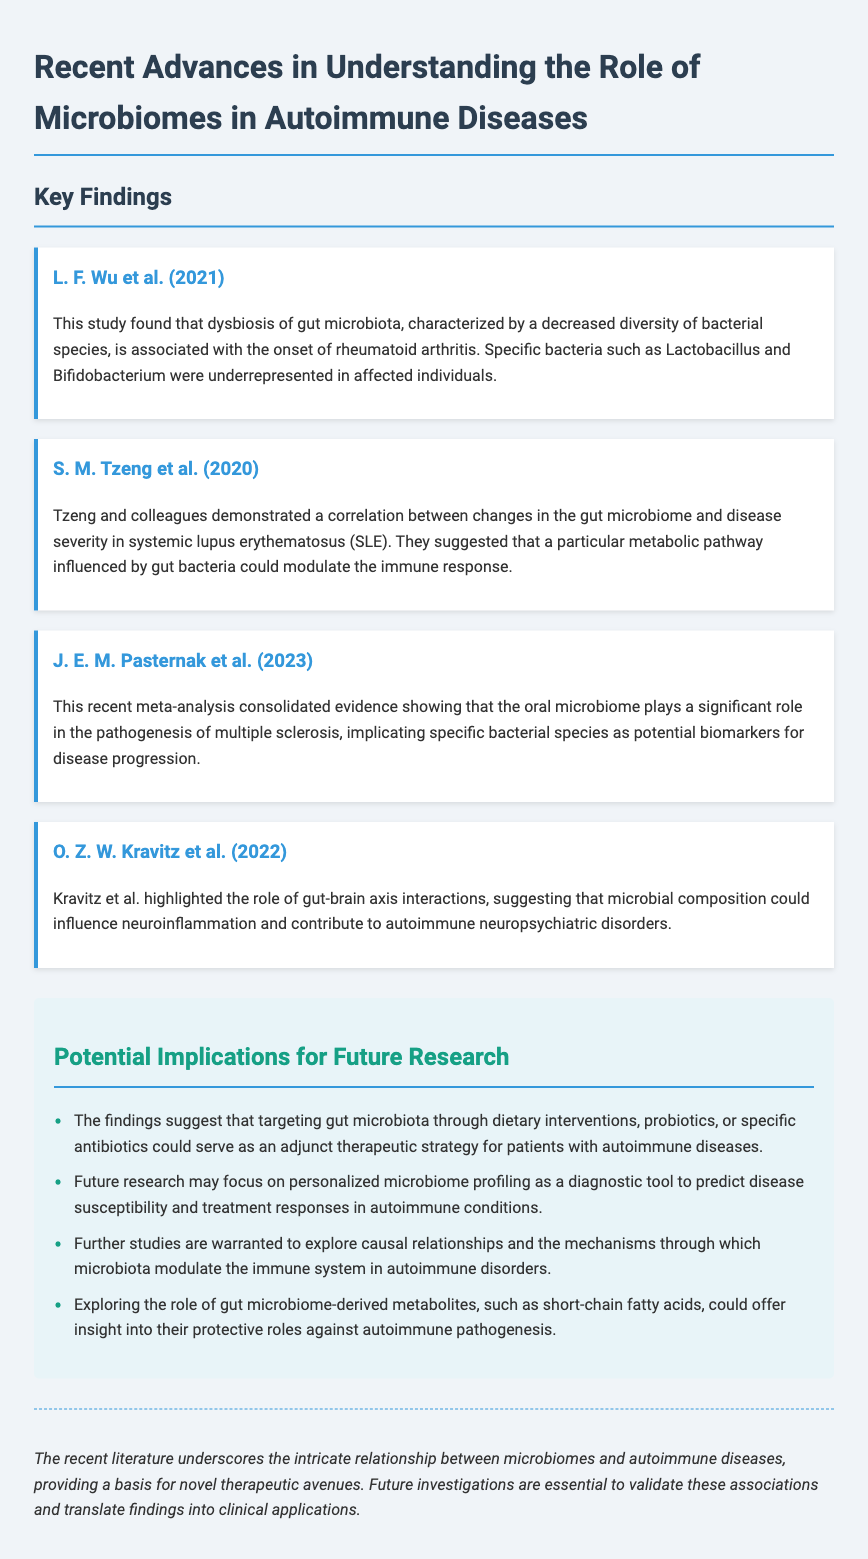What is the title of the document? The title of the document encapsulates the main theme focusing on microbiomes and autoimmune diseases.
Answer: Recent Advances in Understanding the Role of Microbiomes in Autoimmune Diseases Who conducted a study on rheumatoid arthritis? The name of the first author associated with the study on rheumatoid arthritis is mentioned in the document.
Answer: L. F. Wu et al What specific bacteria were underrepresented in rheumatoid arthritis patients? The study outlines specific bacteria linked to a reduction in diversity in affected individuals.
Answer: Lactobacillus and Bifidobacterium What year was the meta-analysis on multiple sclerosis published? The publication year of the meta-analysis concerning the oral microbiome and multiple sclerosis is specified.
Answer: 2023 Which autoimmune disease was shown to have a correlation with gut microbiome changes in Tzeng et al.'s study? The study specifies the disease related to gut microbiome alterations and severity as identified by the authors.
Answer: Systemic lupus erythematosus (SLE) What are potential therapeutic strategies mentioned for autoimmune diseases? The document suggests interventions that can target gut microbiota as an adjunct strategy.
Answer: Dietary interventions, probiotics, or specific antibiotics What should future research focus on regarding microbiome profiling? The document outlines an approach for the future that could enhance diagnostics in autoimmune conditions.
Answer: Personalized microbiome profiling as a diagnostic tool What could gut microbiome-derived metabolites provide insight into? The document indicates the focus area regarding metabolites and their potential role in autoimmune processes.
Answer: Protective roles against autoimmune pathogenesis 